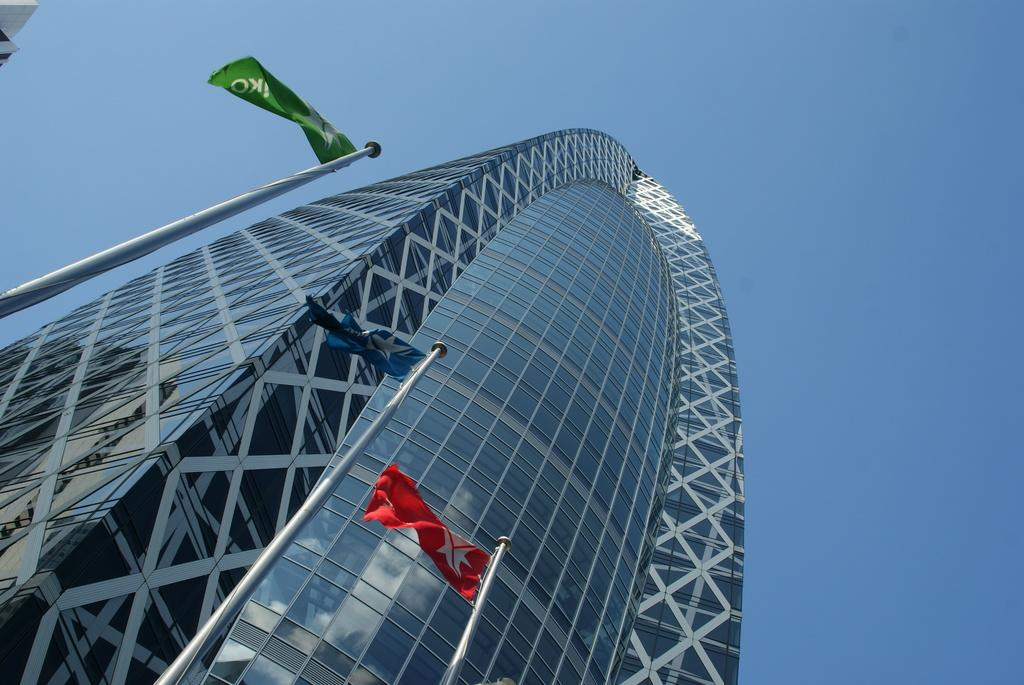What type of building is visible in the image? There is a building with glass in the image. Are there any additional features in front of the building? Flags are attached to poles in front of the building. What can be seen in the background of the image? The sky is visible in the background of the image. What type of linen is draped over the sofa in the image? There is no sofa or linen present in the image; it features a building with glass and flags attached to poles. 